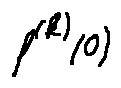<formula> <loc_0><loc_0><loc_500><loc_500>f ^ { ( k ) } ( 0 )</formula> 